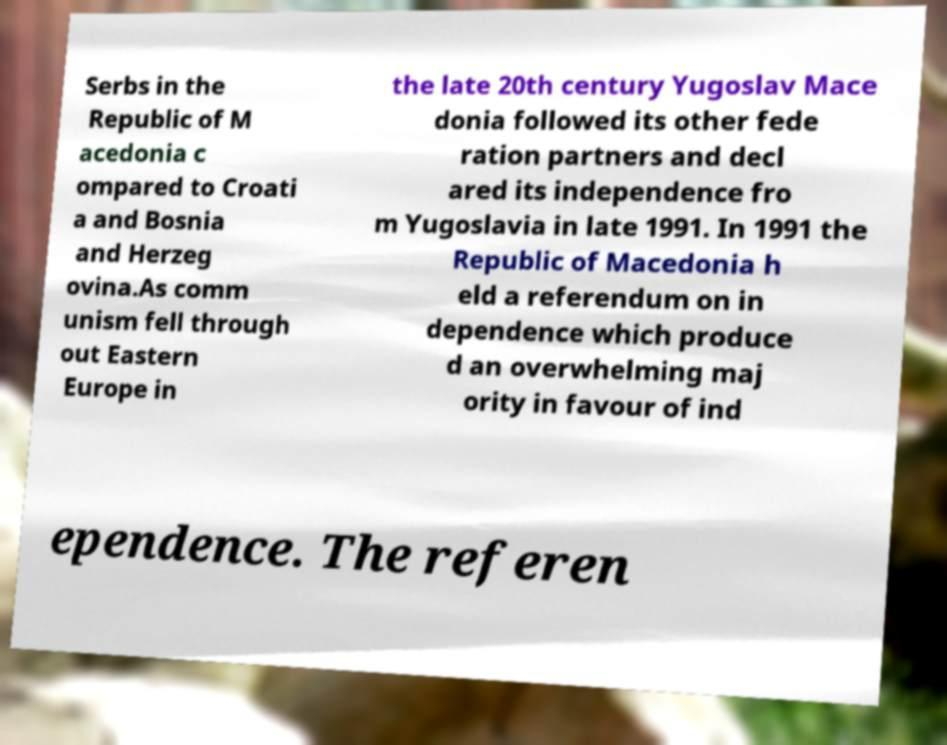Please read and relay the text visible in this image. What does it say? Serbs in the Republic of M acedonia c ompared to Croati a and Bosnia and Herzeg ovina.As comm unism fell through out Eastern Europe in the late 20th century Yugoslav Mace donia followed its other fede ration partners and decl ared its independence fro m Yugoslavia in late 1991. In 1991 the Republic of Macedonia h eld a referendum on in dependence which produce d an overwhelming maj ority in favour of ind ependence. The referen 